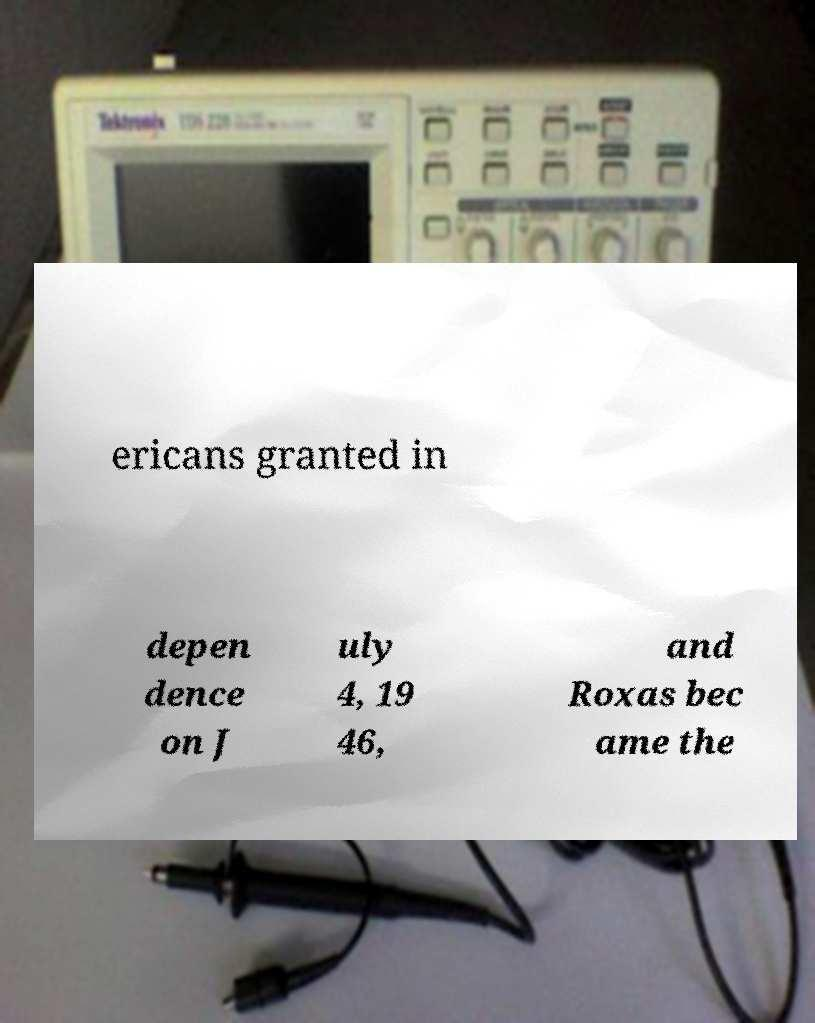For documentation purposes, I need the text within this image transcribed. Could you provide that? ericans granted in depen dence on J uly 4, 19 46, and Roxas bec ame the 